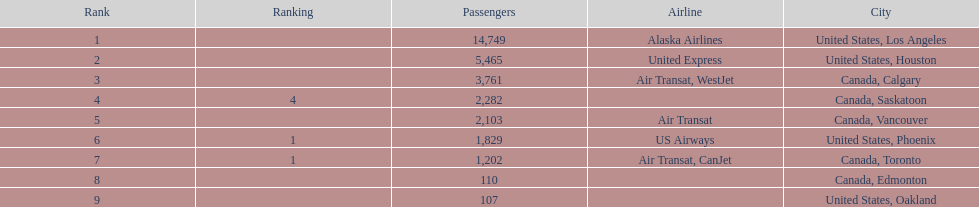How many more passengers flew to los angeles than to saskatoon from manzanillo airport in 2013? 12,467. 